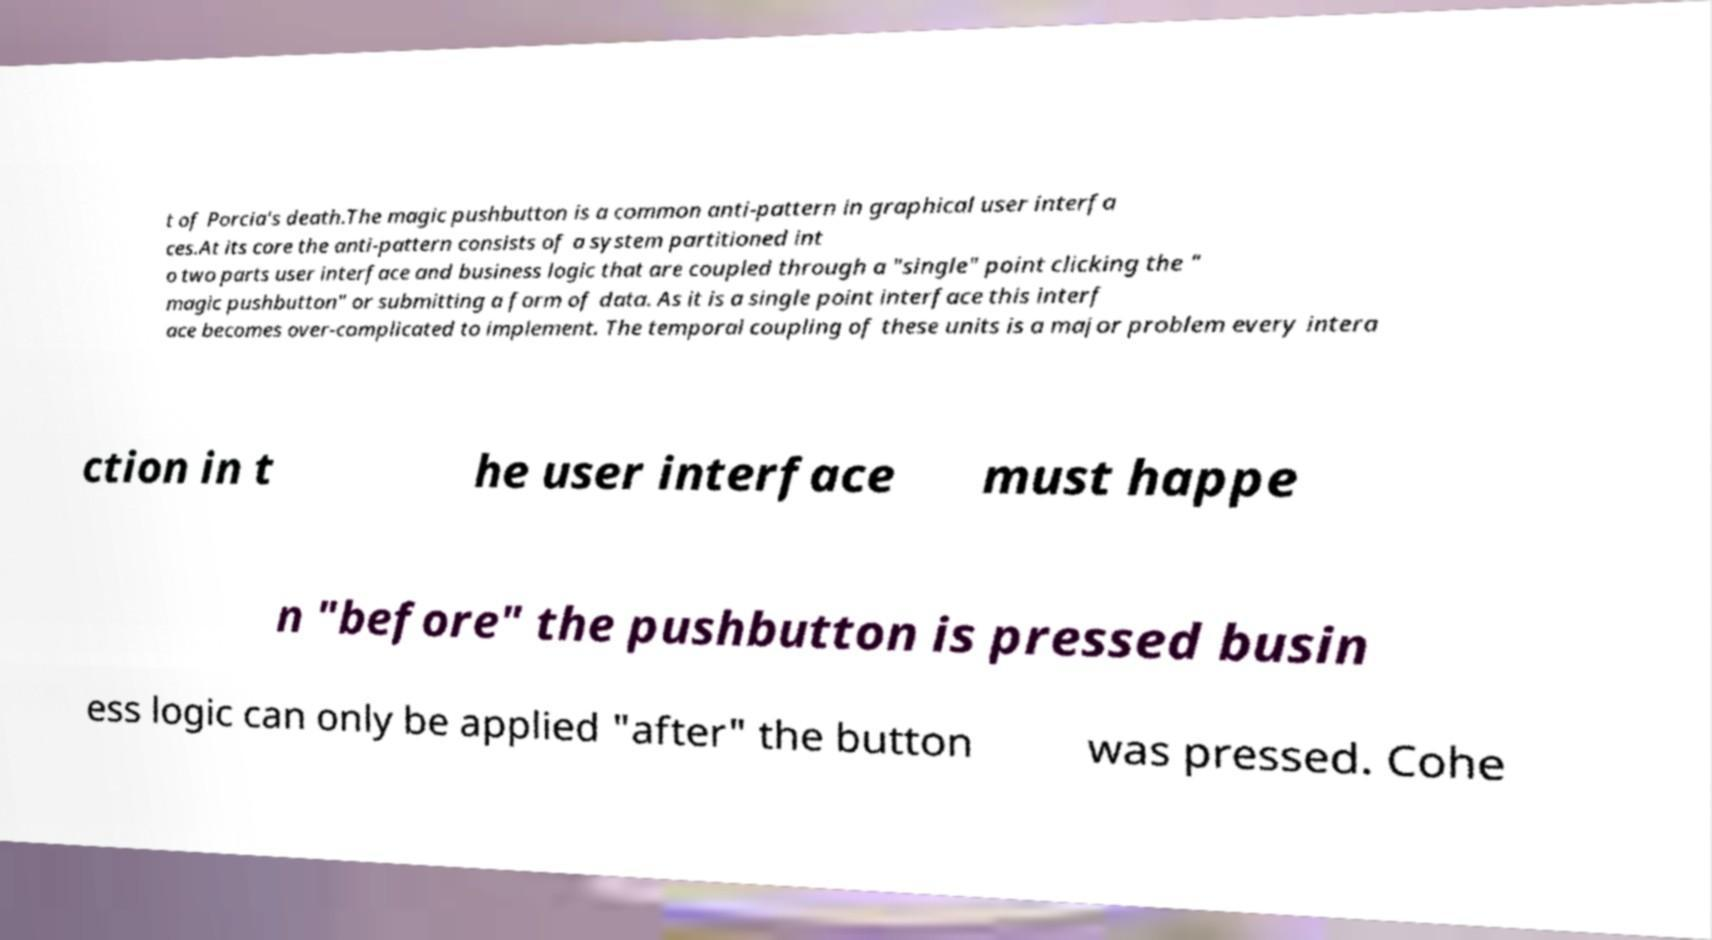Can you accurately transcribe the text from the provided image for me? t of Porcia's death.The magic pushbutton is a common anti-pattern in graphical user interfa ces.At its core the anti-pattern consists of a system partitioned int o two parts user interface and business logic that are coupled through a "single" point clicking the " magic pushbutton" or submitting a form of data. As it is a single point interface this interf ace becomes over-complicated to implement. The temporal coupling of these units is a major problem every intera ction in t he user interface must happe n "before" the pushbutton is pressed busin ess logic can only be applied "after" the button was pressed. Cohe 